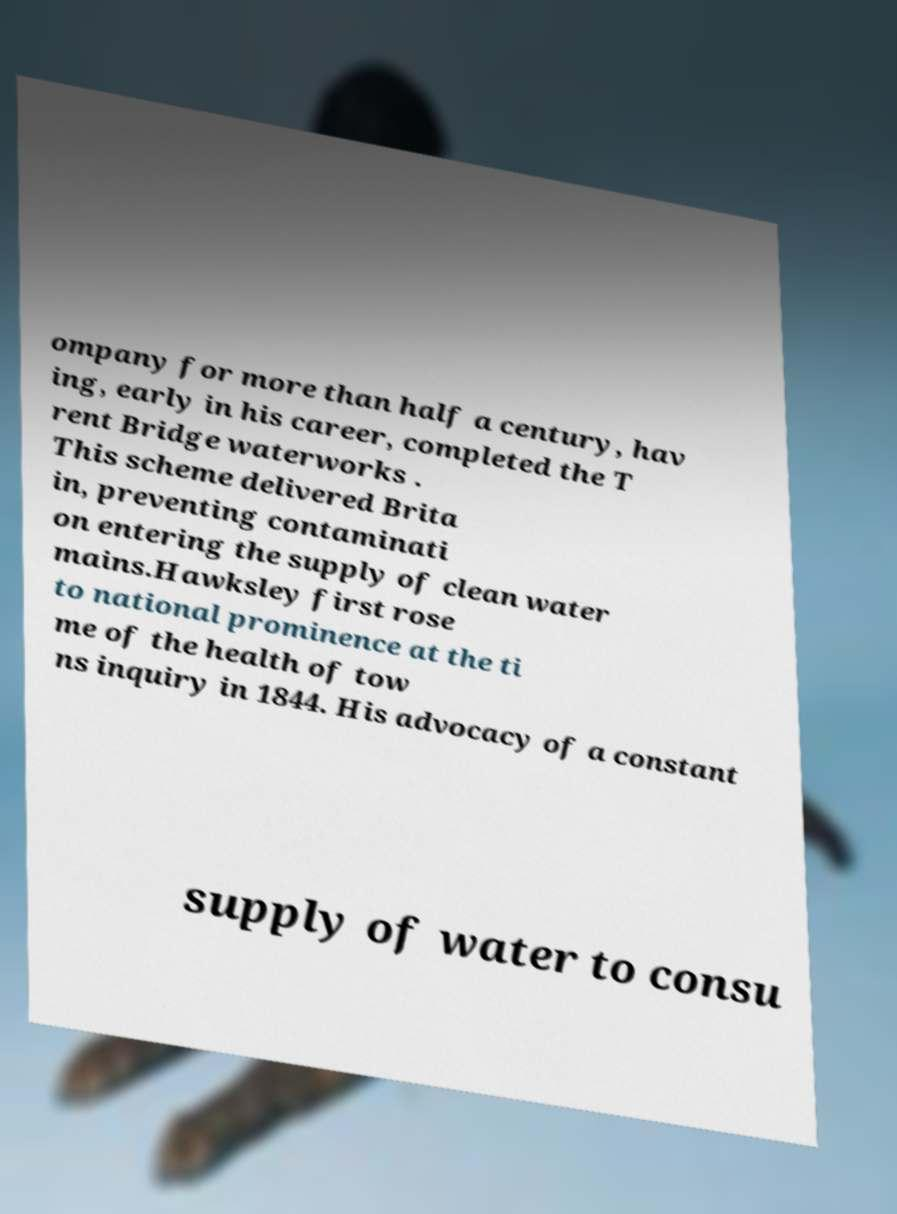For documentation purposes, I need the text within this image transcribed. Could you provide that? ompany for more than half a century, hav ing, early in his career, completed the T rent Bridge waterworks . This scheme delivered Brita in, preventing contaminati on entering the supply of clean water mains.Hawksley first rose to national prominence at the ti me of the health of tow ns inquiry in 1844. His advocacy of a constant supply of water to consu 